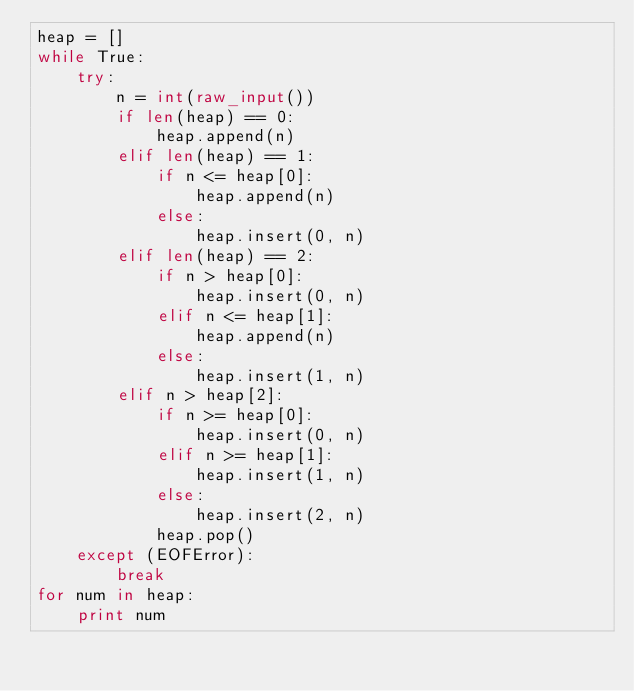<code> <loc_0><loc_0><loc_500><loc_500><_Python_>heap = []
while True:
    try:
        n = int(raw_input())
        if len(heap) == 0:
            heap.append(n)
        elif len(heap) == 1:
            if n <= heap[0]:
                heap.append(n)
            else:
                heap.insert(0, n)
        elif len(heap) == 2:
            if n > heap[0]:
                heap.insert(0, n)
            elif n <= heap[1]:
                heap.append(n)
            else:
                heap.insert(1, n)
        elif n > heap[2]:
            if n >= heap[0]:
                heap.insert(0, n)
            elif n >= heap[1]:
                heap.insert(1, n)
            else:
                heap.insert(2, n)
            heap.pop()
    except (EOFError):
        break
for num in heap:
    print num</code> 